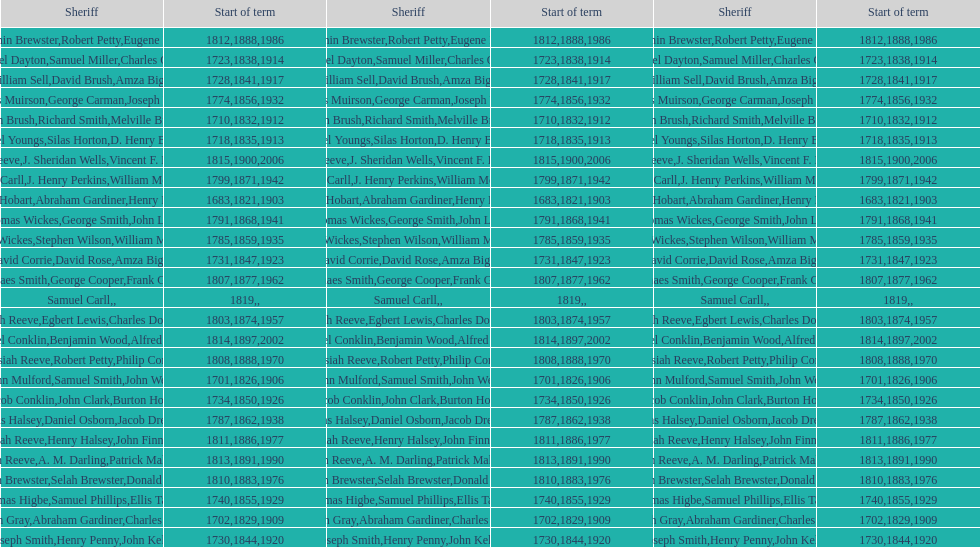Parse the full table. {'header': ['Sheriff', 'Start of term', 'Sheriff', 'Start of term', 'Sheriff', 'Start of term'], 'rows': [['Benjamin Brewster', '1812', 'Robert Petty', '1888', 'Eugene Dooley', '1986'], ['Samuel Dayton', '1723', 'Samuel Miller', '1838', "Charles O'Dell", '1914'], ['William Sell', '1728', 'David Brush', '1841', 'Amza Biggs', '1917'], ['James Muirson', '1774', 'George Carman', '1856', 'Joseph Warta', '1932'], ['John Brush', '1710', 'Richard Smith', '1832', 'Melville Brush', '1912'], ['Daniel Youngs', '1718', 'Silas Horton', '1835', 'D. Henry Brown', '1913'], ['Josiah Reeve', '1815', 'J. Sheridan Wells', '1900', 'Vincent F. DeMarco', '2006'], ['Phinaes Carll', '1799', 'J. Henry Perkins', '1871', 'William McCollom', '1942'], ['Josiah Hobart', '1683', 'Abraham Gardiner', '1821', 'Henry Preston', '1903'], ['Thomas Wickes', '1791', 'George Smith', '1868', 'John Levy', '1941'], ['Thomas Wickes', '1785', 'Stephen Wilson', '1859', 'William McCollom', '1935'], ['David Corrie', '1731', 'David Rose', '1847', 'Amza Biggs', '1923'], ['Phinaes Smith', '1807', 'George Cooper', '1877', 'Frank Gross', '1962'], ['Samuel Carll', '1819', '', '', '', ''], ['Josiah Reeve', '1803', 'Egbert Lewis', '1874', 'Charles Dominy', '1957'], ['Nathaniel Conklin', '1814', 'Benjamin Wood', '1897', 'Alfred C. Tisch', '2002'], ['Josiah Reeve', '1808', 'Robert Petty', '1888', 'Philip Corso', '1970'], ['John Mulford', '1701', 'Samuel Smith', '1826', 'John Wells', '1906'], ['Jacob Conklin', '1734', 'John Clark', '1850', 'Burton Howe', '1926'], ['Silas Halsey', '1787', 'Daniel Osborn', '1862', 'Jacob Dreyer', '1938'], ['Josiah Reeve', '1811', 'Henry Halsey', '1886', 'John Finnerty', '1977'], ['Josiah Reeve', '1813', 'A. M. Darling', '1891', 'Patrick Mahoney', '1990'], ['Benjamin Brewster', '1810', 'Selah Brewster', '1883', 'Donald Dilworth', '1976'], ['Thomas Higbe', '1740', 'Samuel Phillips', '1855', 'Ellis Taylor', '1929'], ['Hugh Gray', '1702', 'Abraham Gardiner', '1829', 'Charles Platt', '1909'], ['Joseph Smith', '1730', 'Henry Penny', '1844', 'John Kelly', '1920']]} Who was the sheriff in suffolk county before amza biggs first term there as sheriff? Charles O'Dell. 